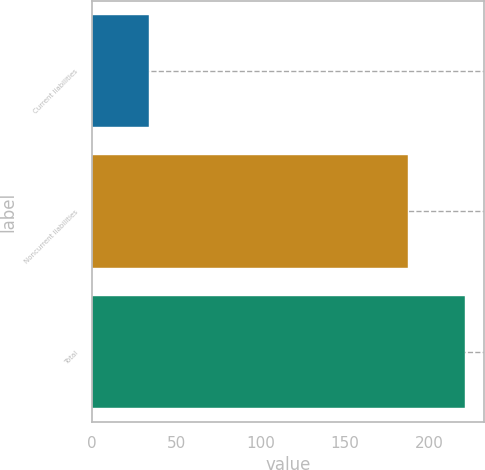<chart> <loc_0><loc_0><loc_500><loc_500><bar_chart><fcel>Current liabilities<fcel>Noncurrent liabilities<fcel>Total<nl><fcel>34<fcel>187<fcel>221<nl></chart> 